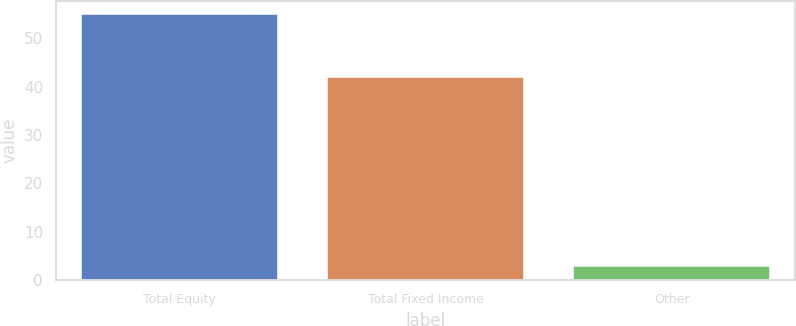<chart> <loc_0><loc_0><loc_500><loc_500><bar_chart><fcel>Total Equity<fcel>Total Fixed Income<fcel>Other<nl><fcel>55<fcel>42<fcel>3<nl></chart> 